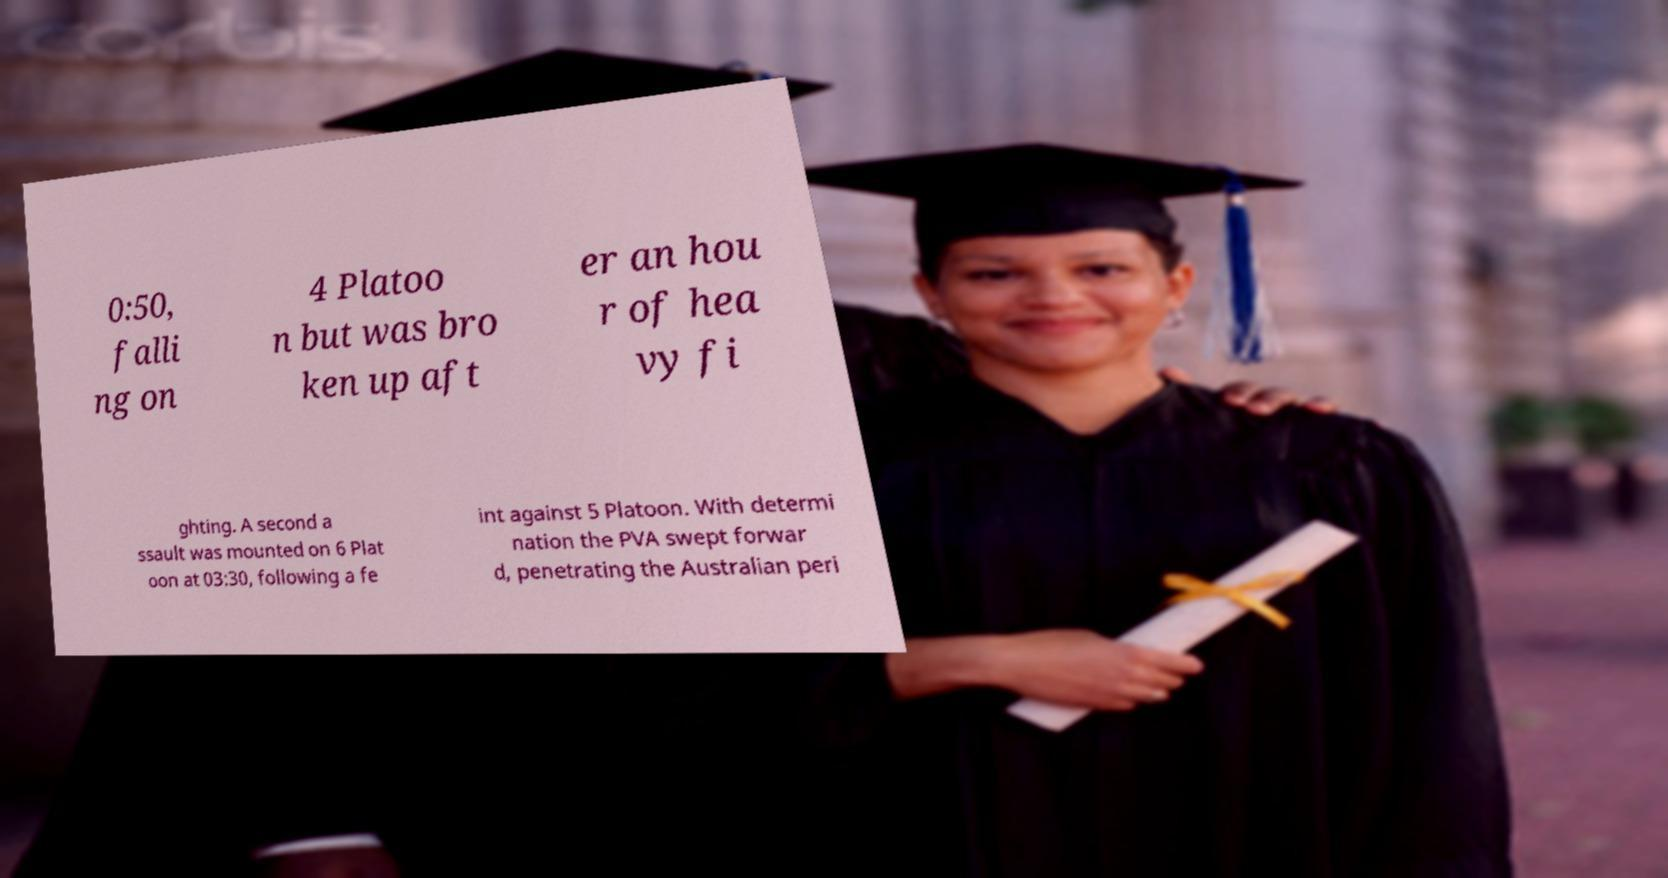Could you extract and type out the text from this image? 0:50, falli ng on 4 Platoo n but was bro ken up aft er an hou r of hea vy fi ghting. A second a ssault was mounted on 6 Plat oon at 03:30, following a fe int against 5 Platoon. With determi nation the PVA swept forwar d, penetrating the Australian peri 